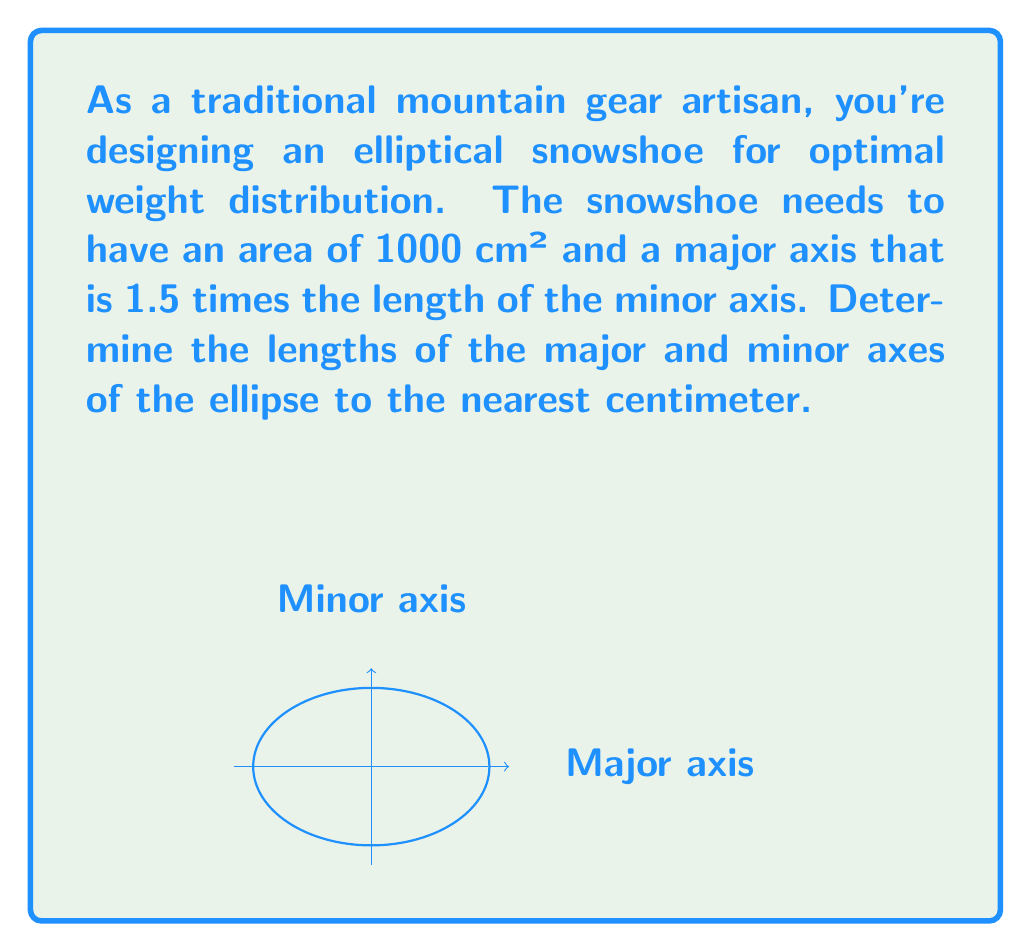Give your solution to this math problem. Let's approach this step-by-step:

1) Let $a$ be half the length of the major axis and $b$ be half the length of the minor axis.

2) Given that the major axis is 1.5 times the minor axis, we can write:
   $2a = 1.5(2b)$ or $a = 1.5b$

3) The area of an ellipse is given by the formula:
   $A = \pi ab$

4) We know the area is 1000 cm², so:
   $1000 = \pi ab$

5) Substituting $a = 1.5b$ from step 2:
   $1000 = \pi(1.5b)b = 1.5\pi b^2$

6) Solving for $b$:
   $b^2 = \frac{1000}{1.5\pi} \approx 212.2$
   $b \approx \sqrt{212.2} \approx 14.57$

7) Rounding to the nearest centimeter:
   $b = 15$ cm

8) Since $a = 1.5b$:
   $a = 1.5(15) = 22.5$ cm

9) The full lengths of the axes are:
   Minor axis: $2b = 30$ cm
   Major axis: $2a = 45$ cm
Answer: Minor axis: 30 cm, Major axis: 45 cm 